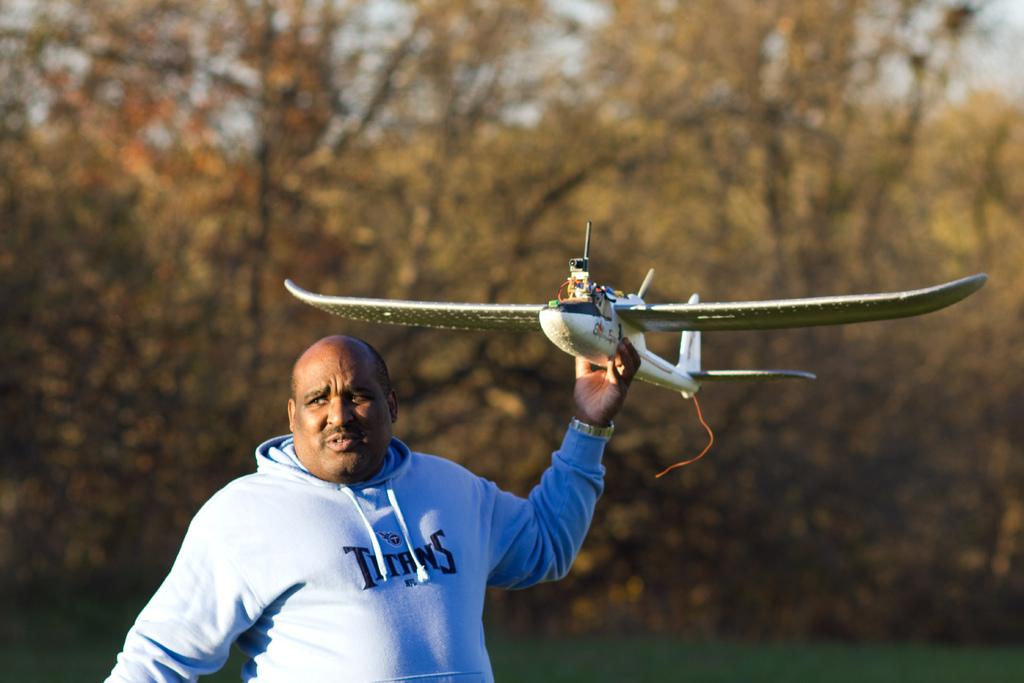What is this man's favorite team?
Your answer should be very brief. Titans. 